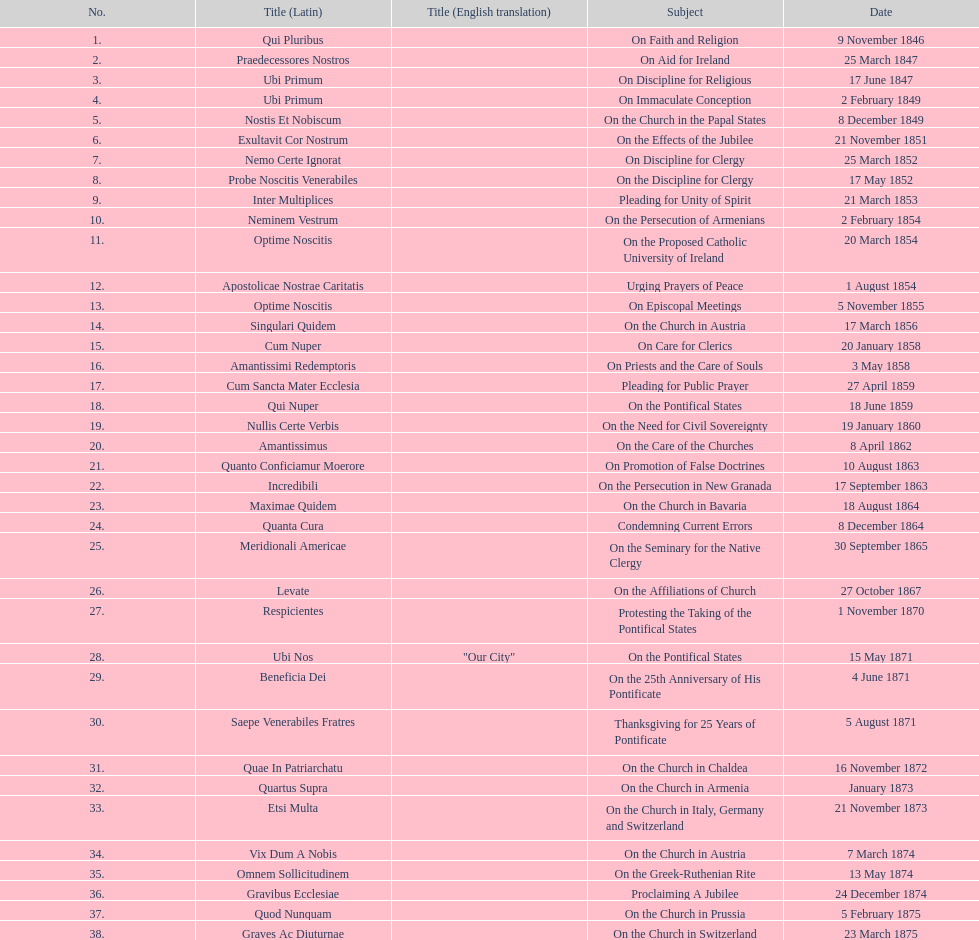Date of the last encyclical whose subject contained the word "pontificate" 5 August 1871. 